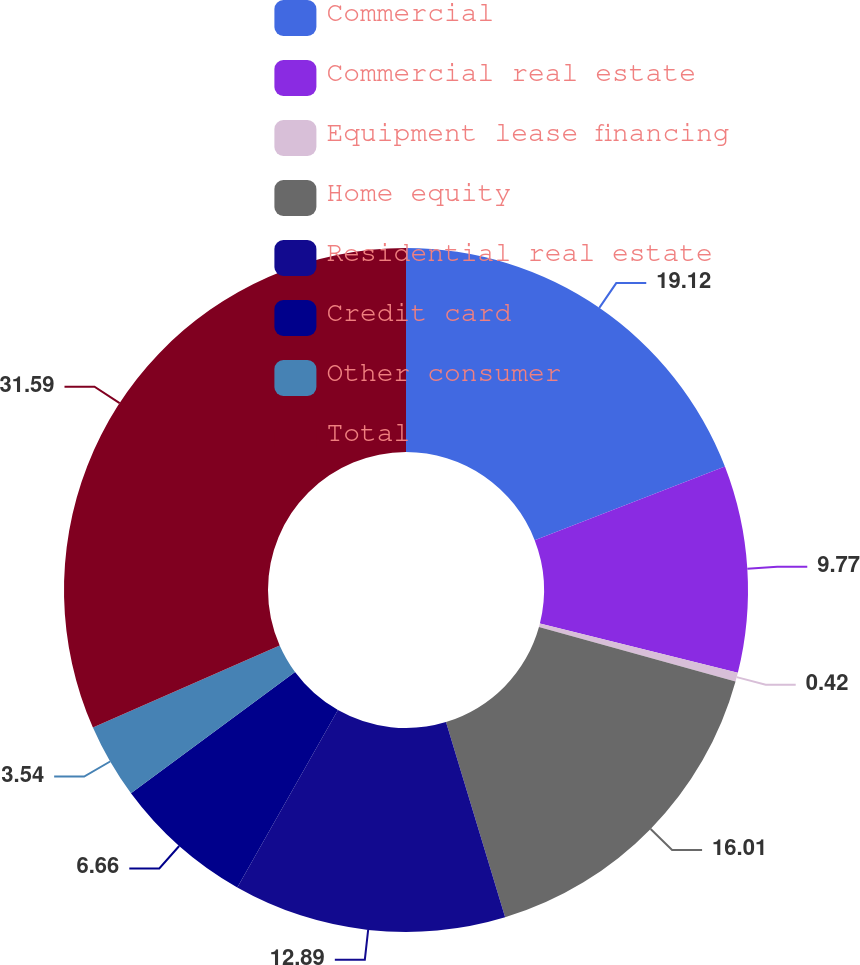Convert chart to OTSL. <chart><loc_0><loc_0><loc_500><loc_500><pie_chart><fcel>Commercial<fcel>Commercial real estate<fcel>Equipment lease financing<fcel>Home equity<fcel>Residential real estate<fcel>Credit card<fcel>Other consumer<fcel>Total<nl><fcel>19.12%<fcel>9.77%<fcel>0.42%<fcel>16.01%<fcel>12.89%<fcel>6.66%<fcel>3.54%<fcel>31.59%<nl></chart> 